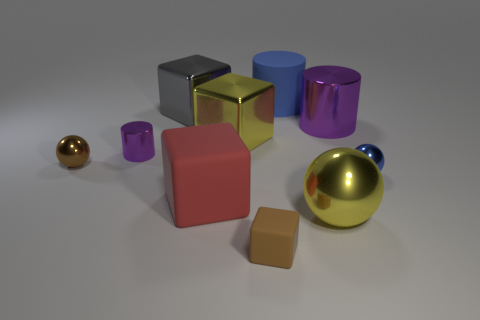Are there any other things that have the same color as the big sphere?
Keep it short and to the point. Yes. Is the shape of the big red matte thing the same as the yellow metallic object behind the tiny purple metal cylinder?
Your response must be concise. Yes. Is the color of the large metallic cylinder the same as the small cylinder?
Offer a terse response. Yes. The big block in front of the purple cylinder to the left of the large gray thing is made of what material?
Keep it short and to the point. Rubber. Is there a big red object that has the same shape as the small purple object?
Make the answer very short. No. There is a matte cube that is the same size as the blue shiny sphere; what is its color?
Your response must be concise. Brown. How many things are either small brown things in front of the red rubber cube or balls right of the rubber cylinder?
Provide a succinct answer. 3. How many things are brown metal objects or blue rubber objects?
Offer a very short reply. 2. There is a metallic object that is both in front of the small purple metallic cylinder and left of the small cube; how big is it?
Provide a short and direct response. Small. What number of blue objects are the same material as the small brown cube?
Your answer should be very brief. 1. 